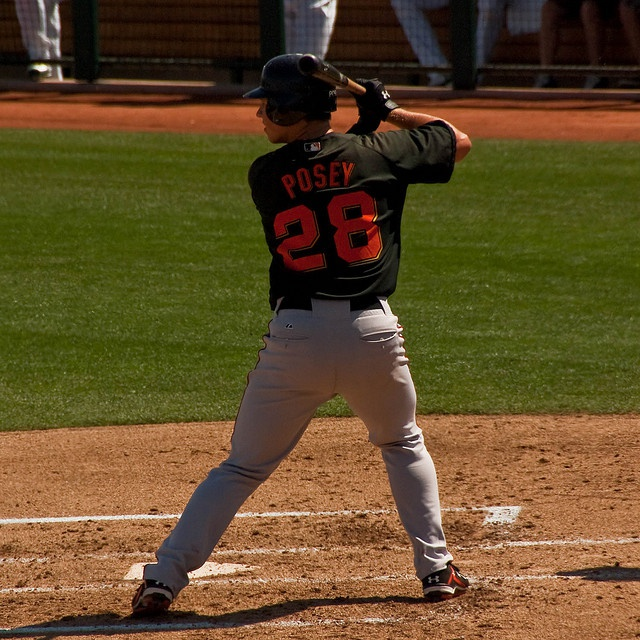Describe the objects in this image and their specific colors. I can see people in black, maroon, darkgreen, and gray tones, people in black, gray, and darkgray tones, baseball bat in black, maroon, gray, and darkgray tones, and baseball glove in black, gray, maroon, and darkgray tones in this image. 